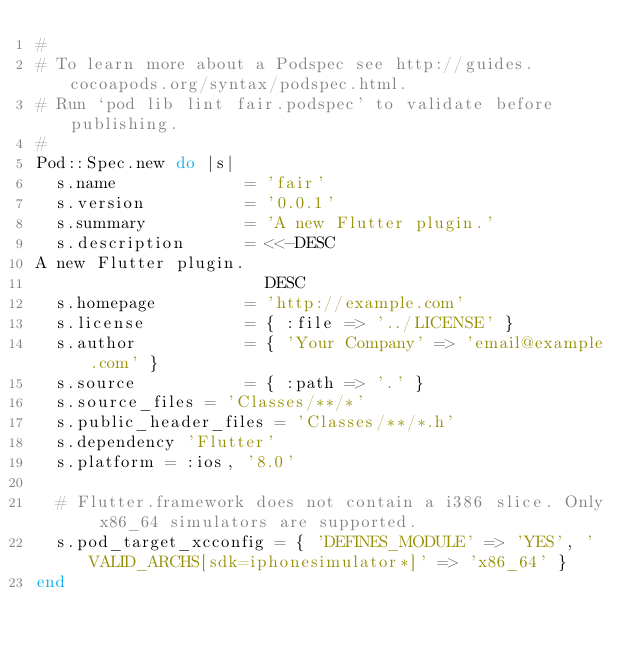<code> <loc_0><loc_0><loc_500><loc_500><_Ruby_>#
# To learn more about a Podspec see http://guides.cocoapods.org/syntax/podspec.html.
# Run `pod lib lint fair.podspec' to validate before publishing.
#
Pod::Spec.new do |s|
  s.name             = 'fair'
  s.version          = '0.0.1'
  s.summary          = 'A new Flutter plugin.'
  s.description      = <<-DESC
A new Flutter plugin.
                       DESC
  s.homepage         = 'http://example.com'
  s.license          = { :file => '../LICENSE' }
  s.author           = { 'Your Company' => 'email@example.com' }
  s.source           = { :path => '.' }
  s.source_files = 'Classes/**/*'
  s.public_header_files = 'Classes/**/*.h'
  s.dependency 'Flutter'
  s.platform = :ios, '8.0'

  # Flutter.framework does not contain a i386 slice. Only x86_64 simulators are supported.
  s.pod_target_xcconfig = { 'DEFINES_MODULE' => 'YES', 'VALID_ARCHS[sdk=iphonesimulator*]' => 'x86_64' }
end
</code> 